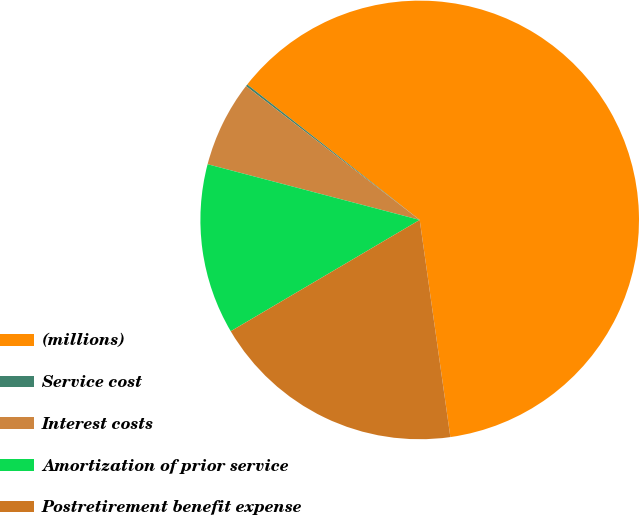<chart> <loc_0><loc_0><loc_500><loc_500><pie_chart><fcel>(millions)<fcel>Service cost<fcel>Interest costs<fcel>Amortization of prior service<fcel>Postretirement benefit expense<nl><fcel>62.17%<fcel>0.15%<fcel>6.36%<fcel>12.56%<fcel>18.76%<nl></chart> 